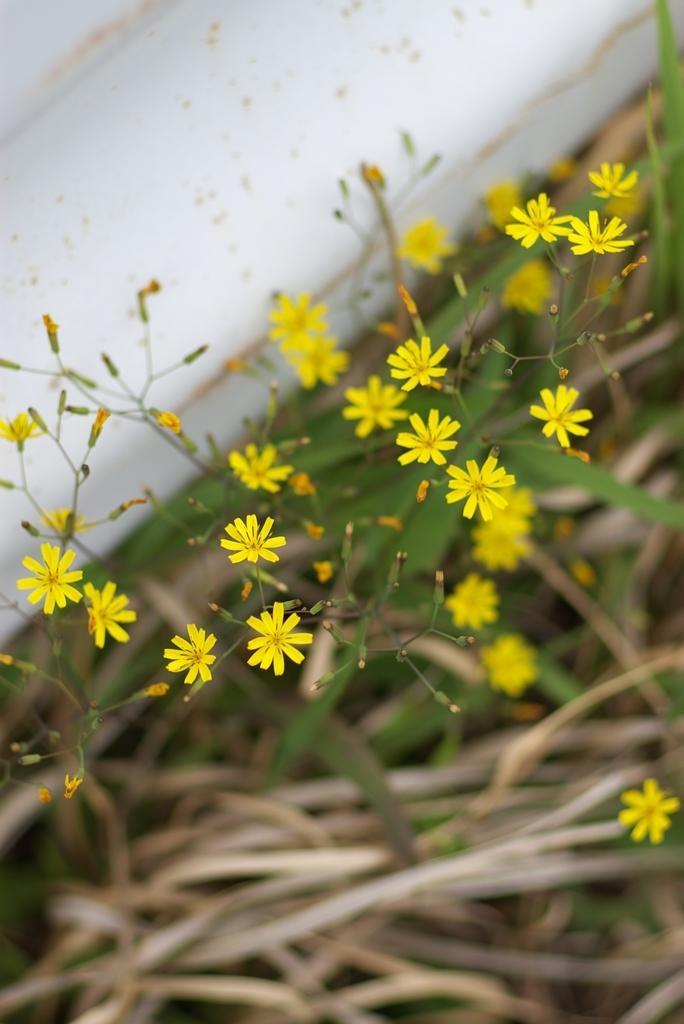In one or two sentences, can you explain what this image depicts? In the center of the image there are flowers and leaves. 